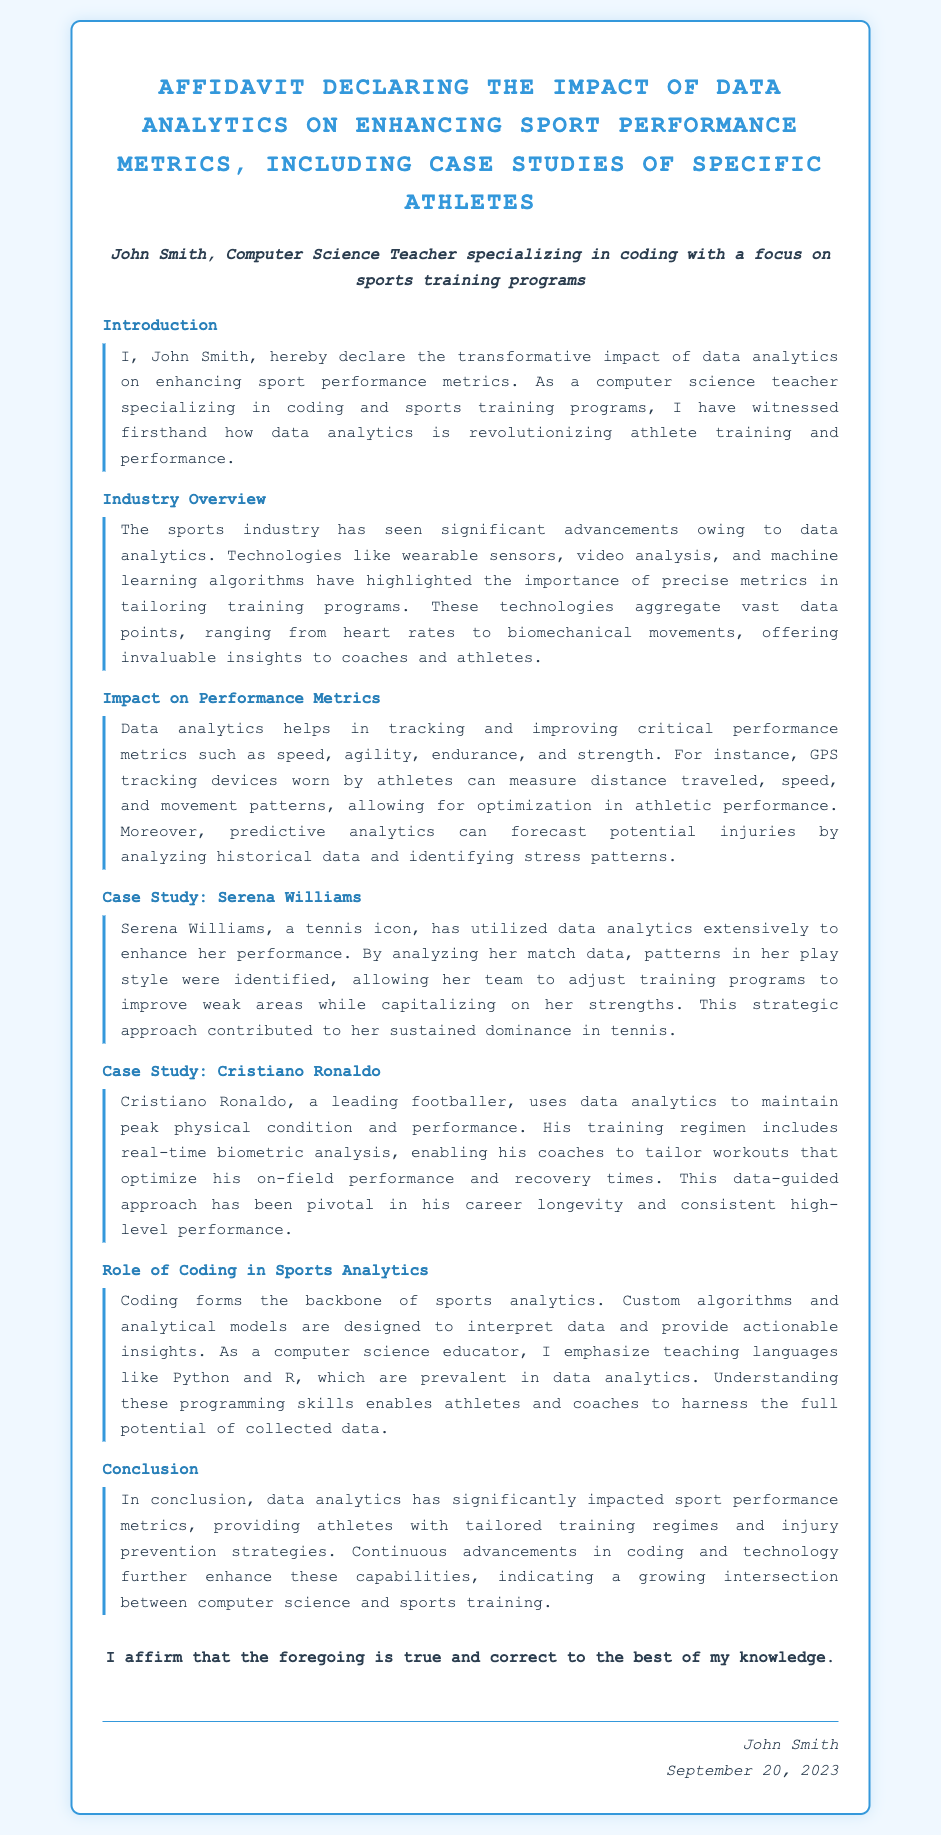what is the name of the affiant? The affiant is the individual who makes the affidavit, in this case, it is John Smith, as stated at the beginning of the document.
Answer: John Smith what is the main focus of the affiant's teaching? The document specifies that the affiant specializes in coding with a focus on sports training programs.
Answer: coding and sports training programs which athlete is mentioned as a case study? The affidavit discusses two case studies, specifically naming Serena Williams and Cristiano Ronaldo.
Answer: Serena Williams, Cristiano Ronaldo what type of technologies are highlighted in the industry overview? The document mentions wearable sensors, video analysis, and machine learning algorithms as significant technologies in sports analytics.
Answer: wearable sensors, video analysis, machine learning algorithms what key metric does data analytics help track and improve? The affidavit states that data analytics helps in tracking critical performance metrics such as speed, agility, endurance, and strength.
Answer: speed, agility, endurance, strength which programming languages are emphasized for teaching in relation to data analytics? The affiant highlights Python and R as prevalent programming languages used in data analytics.
Answer: Python and R when was the affidavit signed? The date indicated at the end of the affidavit, which confirms the signing, is September 20, 2023.
Answer: September 20, 2023 how does coding relate to sports analytics according to the document? The affidavit states that coding forms the backbone of sports analytics, as it enables the interpretation of data and provides actionable insights.
Answer: backbone of sports analytics what aspect of performance does predictive analytics forecast? Predictive analytics forecasts potential injuries by analyzing historical data and identifying stress patterns.
Answer: potential injuries 